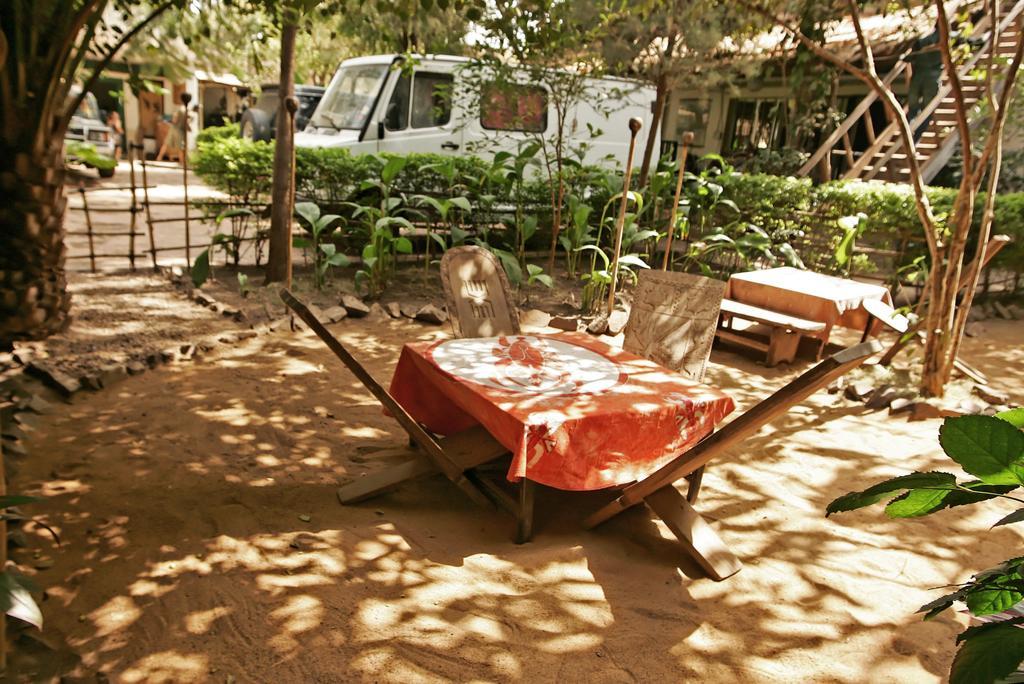In one or two sentences, can you explain what this image depicts? In this image in the middle, there is a table on that there is a cloth, around that there are four chairs. On the right there are plants. In the background there are plants, vehicles, trees, houses and land. 